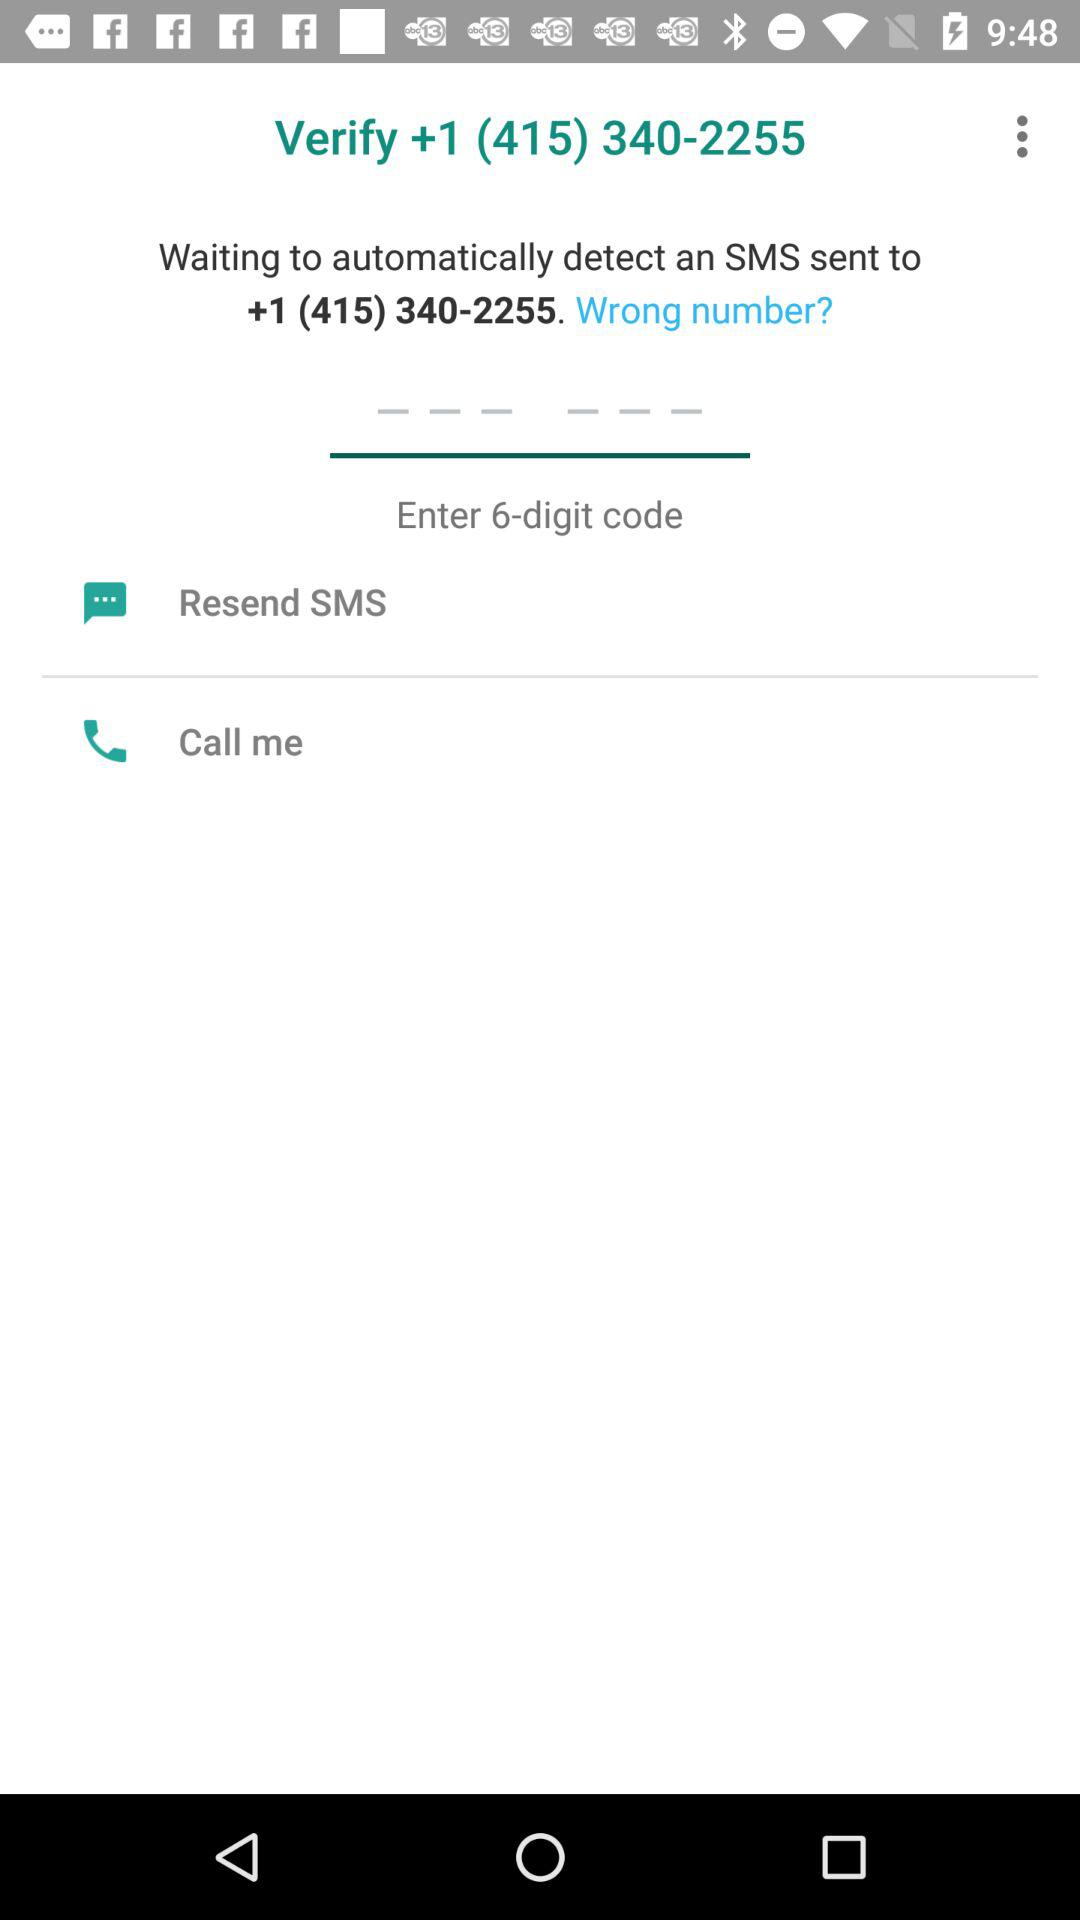How many options are there to resend the code?
Answer the question using a single word or phrase. 2 